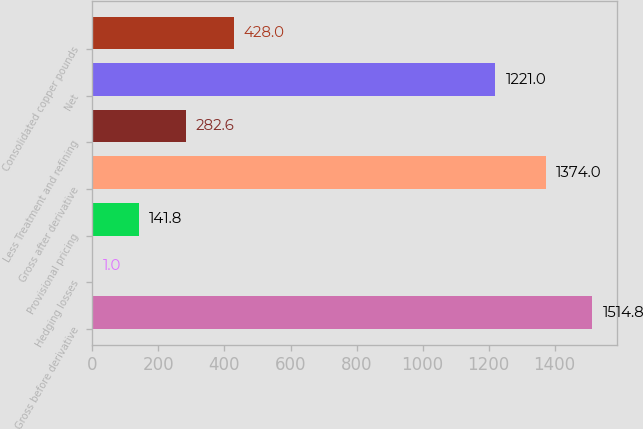<chart> <loc_0><loc_0><loc_500><loc_500><bar_chart><fcel>Gross before derivative<fcel>Hedging losses<fcel>Provisional pricing<fcel>Gross after derivative<fcel>Less Treatment and refining<fcel>Net<fcel>Consolidated copper pounds<nl><fcel>1514.8<fcel>1<fcel>141.8<fcel>1374<fcel>282.6<fcel>1221<fcel>428<nl></chart> 